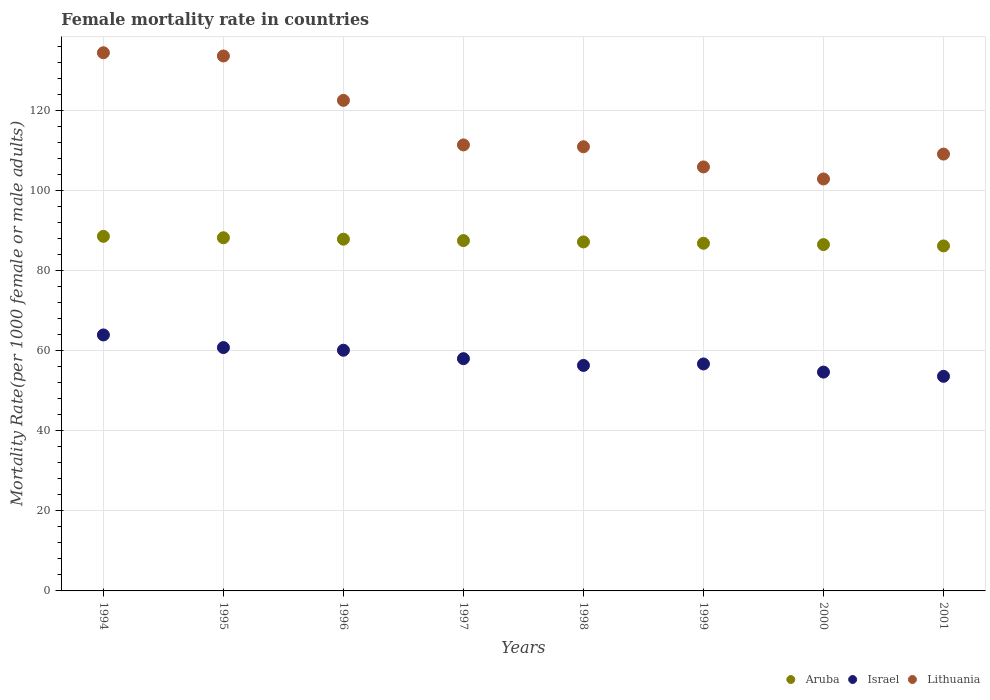Is the number of dotlines equal to the number of legend labels?
Make the answer very short. Yes. What is the female mortality rate in Lithuania in 1994?
Provide a succinct answer. 134.55. Across all years, what is the maximum female mortality rate in Lithuania?
Offer a terse response. 134.55. Across all years, what is the minimum female mortality rate in Israel?
Give a very brief answer. 53.65. In which year was the female mortality rate in Aruba minimum?
Your answer should be very brief. 2001. What is the total female mortality rate in Israel in the graph?
Offer a terse response. 464.58. What is the difference between the female mortality rate in Lithuania in 1998 and that in 2001?
Your response must be concise. 1.84. What is the difference between the female mortality rate in Lithuania in 1998 and the female mortality rate in Aruba in 1995?
Provide a succinct answer. 22.76. What is the average female mortality rate in Israel per year?
Offer a very short reply. 58.07. In the year 2000, what is the difference between the female mortality rate in Aruba and female mortality rate in Lithuania?
Offer a very short reply. -16.41. In how many years, is the female mortality rate in Israel greater than 4?
Offer a terse response. 8. What is the ratio of the female mortality rate in Israel in 1994 to that in 1999?
Your answer should be compact. 1.13. What is the difference between the highest and the second highest female mortality rate in Lithuania?
Your answer should be compact. 0.81. What is the difference between the highest and the lowest female mortality rate in Aruba?
Give a very brief answer. 2.4. Does the female mortality rate in Aruba monotonically increase over the years?
Provide a short and direct response. No. How many dotlines are there?
Your answer should be very brief. 3. Are the values on the major ticks of Y-axis written in scientific E-notation?
Provide a succinct answer. No. Does the graph contain any zero values?
Your answer should be very brief. No. Where does the legend appear in the graph?
Provide a short and direct response. Bottom right. How many legend labels are there?
Keep it short and to the point. 3. How are the legend labels stacked?
Give a very brief answer. Horizontal. What is the title of the graph?
Provide a short and direct response. Female mortality rate in countries. What is the label or title of the Y-axis?
Your answer should be very brief. Mortality Rate(per 1000 female or male adults). What is the Mortality Rate(per 1000 female or male adults) of Aruba in 1994?
Offer a terse response. 88.65. What is the Mortality Rate(per 1000 female or male adults) of Israel in 1994?
Provide a succinct answer. 64. What is the Mortality Rate(per 1000 female or male adults) of Lithuania in 1994?
Give a very brief answer. 134.55. What is the Mortality Rate(per 1000 female or male adults) of Aruba in 1995?
Keep it short and to the point. 88.3. What is the Mortality Rate(per 1000 female or male adults) in Israel in 1995?
Your answer should be very brief. 60.84. What is the Mortality Rate(per 1000 female or male adults) of Lithuania in 1995?
Keep it short and to the point. 133.74. What is the Mortality Rate(per 1000 female or male adults) of Aruba in 1996?
Your response must be concise. 87.94. What is the Mortality Rate(per 1000 female or male adults) in Israel in 1996?
Your answer should be very brief. 60.18. What is the Mortality Rate(per 1000 female or male adults) of Lithuania in 1996?
Make the answer very short. 122.65. What is the Mortality Rate(per 1000 female or male adults) in Aruba in 1997?
Give a very brief answer. 87.59. What is the Mortality Rate(per 1000 female or male adults) in Israel in 1997?
Offer a very short reply. 58.07. What is the Mortality Rate(per 1000 female or male adults) in Lithuania in 1997?
Offer a terse response. 111.5. What is the Mortality Rate(per 1000 female or male adults) in Aruba in 1998?
Your answer should be very brief. 87.25. What is the Mortality Rate(per 1000 female or male adults) in Israel in 1998?
Ensure brevity in your answer.  56.38. What is the Mortality Rate(per 1000 female or male adults) of Lithuania in 1998?
Provide a short and direct response. 111.05. What is the Mortality Rate(per 1000 female or male adults) of Aruba in 1999?
Your answer should be compact. 86.92. What is the Mortality Rate(per 1000 female or male adults) in Israel in 1999?
Keep it short and to the point. 56.74. What is the Mortality Rate(per 1000 female or male adults) in Lithuania in 1999?
Provide a short and direct response. 106. What is the Mortality Rate(per 1000 female or male adults) in Aruba in 2000?
Make the answer very short. 86.59. What is the Mortality Rate(per 1000 female or male adults) in Israel in 2000?
Your answer should be compact. 54.71. What is the Mortality Rate(per 1000 female or male adults) of Lithuania in 2000?
Give a very brief answer. 102.99. What is the Mortality Rate(per 1000 female or male adults) of Aruba in 2001?
Offer a very short reply. 86.25. What is the Mortality Rate(per 1000 female or male adults) in Israel in 2001?
Provide a succinct answer. 53.65. What is the Mortality Rate(per 1000 female or male adults) in Lithuania in 2001?
Make the answer very short. 109.22. Across all years, what is the maximum Mortality Rate(per 1000 female or male adults) of Aruba?
Provide a short and direct response. 88.65. Across all years, what is the maximum Mortality Rate(per 1000 female or male adults) in Israel?
Make the answer very short. 64. Across all years, what is the maximum Mortality Rate(per 1000 female or male adults) in Lithuania?
Offer a very short reply. 134.55. Across all years, what is the minimum Mortality Rate(per 1000 female or male adults) of Aruba?
Provide a succinct answer. 86.25. Across all years, what is the minimum Mortality Rate(per 1000 female or male adults) of Israel?
Your answer should be very brief. 53.65. Across all years, what is the minimum Mortality Rate(per 1000 female or male adults) of Lithuania?
Offer a terse response. 102.99. What is the total Mortality Rate(per 1000 female or male adults) in Aruba in the graph?
Your response must be concise. 699.5. What is the total Mortality Rate(per 1000 female or male adults) in Israel in the graph?
Your response must be concise. 464.58. What is the total Mortality Rate(per 1000 female or male adults) in Lithuania in the graph?
Keep it short and to the point. 931.71. What is the difference between the Mortality Rate(per 1000 female or male adults) in Aruba in 1994 and that in 1995?
Provide a succinct answer. 0.35. What is the difference between the Mortality Rate(per 1000 female or male adults) of Israel in 1994 and that in 1995?
Give a very brief answer. 3.16. What is the difference between the Mortality Rate(per 1000 female or male adults) of Lithuania in 1994 and that in 1995?
Make the answer very short. 0.81. What is the difference between the Mortality Rate(per 1000 female or male adults) in Aruba in 1994 and that in 1996?
Ensure brevity in your answer.  0.71. What is the difference between the Mortality Rate(per 1000 female or male adults) of Israel in 1994 and that in 1996?
Your response must be concise. 3.82. What is the difference between the Mortality Rate(per 1000 female or male adults) in Lithuania in 1994 and that in 1996?
Provide a succinct answer. 11.9. What is the difference between the Mortality Rate(per 1000 female or male adults) of Aruba in 1994 and that in 1997?
Give a very brief answer. 1.06. What is the difference between the Mortality Rate(per 1000 female or male adults) in Israel in 1994 and that in 1997?
Your response must be concise. 5.93. What is the difference between the Mortality Rate(per 1000 female or male adults) of Lithuania in 1994 and that in 1997?
Offer a very short reply. 23.05. What is the difference between the Mortality Rate(per 1000 female or male adults) in Aruba in 1994 and that in 1998?
Make the answer very short. 1.4. What is the difference between the Mortality Rate(per 1000 female or male adults) of Israel in 1994 and that in 1998?
Offer a very short reply. 7.62. What is the difference between the Mortality Rate(per 1000 female or male adults) in Lithuania in 1994 and that in 1998?
Offer a terse response. 23.5. What is the difference between the Mortality Rate(per 1000 female or male adults) in Aruba in 1994 and that in 1999?
Keep it short and to the point. 1.73. What is the difference between the Mortality Rate(per 1000 female or male adults) in Israel in 1994 and that in 1999?
Offer a very short reply. 7.25. What is the difference between the Mortality Rate(per 1000 female or male adults) of Lithuania in 1994 and that in 1999?
Your answer should be compact. 28.55. What is the difference between the Mortality Rate(per 1000 female or male adults) of Aruba in 1994 and that in 2000?
Offer a very short reply. 2.06. What is the difference between the Mortality Rate(per 1000 female or male adults) in Israel in 1994 and that in 2000?
Keep it short and to the point. 9.29. What is the difference between the Mortality Rate(per 1000 female or male adults) in Lithuania in 1994 and that in 2000?
Give a very brief answer. 31.56. What is the difference between the Mortality Rate(per 1000 female or male adults) in Aruba in 1994 and that in 2001?
Your answer should be compact. 2.4. What is the difference between the Mortality Rate(per 1000 female or male adults) in Israel in 1994 and that in 2001?
Provide a succinct answer. 10.35. What is the difference between the Mortality Rate(per 1000 female or male adults) of Lithuania in 1994 and that in 2001?
Provide a short and direct response. 25.34. What is the difference between the Mortality Rate(per 1000 female or male adults) in Aruba in 1995 and that in 1996?
Make the answer very short. 0.35. What is the difference between the Mortality Rate(per 1000 female or male adults) of Israel in 1995 and that in 1996?
Offer a terse response. 0.67. What is the difference between the Mortality Rate(per 1000 female or male adults) of Lithuania in 1995 and that in 1996?
Make the answer very short. 11.1. What is the difference between the Mortality Rate(per 1000 female or male adults) in Aruba in 1995 and that in 1997?
Your answer should be compact. 0.71. What is the difference between the Mortality Rate(per 1000 female or male adults) of Israel in 1995 and that in 1997?
Provide a short and direct response. 2.77. What is the difference between the Mortality Rate(per 1000 female or male adults) in Lithuania in 1995 and that in 1997?
Give a very brief answer. 22.24. What is the difference between the Mortality Rate(per 1000 female or male adults) of Aruba in 1995 and that in 1998?
Offer a very short reply. 1.04. What is the difference between the Mortality Rate(per 1000 female or male adults) of Israel in 1995 and that in 1998?
Ensure brevity in your answer.  4.46. What is the difference between the Mortality Rate(per 1000 female or male adults) of Lithuania in 1995 and that in 1998?
Keep it short and to the point. 22.69. What is the difference between the Mortality Rate(per 1000 female or male adults) in Aruba in 1995 and that in 1999?
Your answer should be very brief. 1.38. What is the difference between the Mortality Rate(per 1000 female or male adults) in Israel in 1995 and that in 1999?
Keep it short and to the point. 4.1. What is the difference between the Mortality Rate(per 1000 female or male adults) of Lithuania in 1995 and that in 1999?
Your answer should be compact. 27.74. What is the difference between the Mortality Rate(per 1000 female or male adults) of Aruba in 1995 and that in 2000?
Your answer should be very brief. 1.71. What is the difference between the Mortality Rate(per 1000 female or male adults) of Israel in 1995 and that in 2000?
Provide a succinct answer. 6.13. What is the difference between the Mortality Rate(per 1000 female or male adults) of Lithuania in 1995 and that in 2000?
Provide a short and direct response. 30.75. What is the difference between the Mortality Rate(per 1000 female or male adults) in Aruba in 1995 and that in 2001?
Your answer should be compact. 2.04. What is the difference between the Mortality Rate(per 1000 female or male adults) in Israel in 1995 and that in 2001?
Your answer should be very brief. 7.19. What is the difference between the Mortality Rate(per 1000 female or male adults) in Lithuania in 1995 and that in 2001?
Give a very brief answer. 24.53. What is the difference between the Mortality Rate(per 1000 female or male adults) of Aruba in 1996 and that in 1997?
Your answer should be very brief. 0.35. What is the difference between the Mortality Rate(per 1000 female or male adults) in Israel in 1996 and that in 1997?
Make the answer very short. 2.11. What is the difference between the Mortality Rate(per 1000 female or male adults) in Lithuania in 1996 and that in 1997?
Your answer should be compact. 11.14. What is the difference between the Mortality Rate(per 1000 female or male adults) of Aruba in 1996 and that in 1998?
Offer a terse response. 0.69. What is the difference between the Mortality Rate(per 1000 female or male adults) of Israel in 1996 and that in 1998?
Your answer should be compact. 3.8. What is the difference between the Mortality Rate(per 1000 female or male adults) in Lithuania in 1996 and that in 1998?
Give a very brief answer. 11.59. What is the difference between the Mortality Rate(per 1000 female or male adults) in Aruba in 1996 and that in 1999?
Ensure brevity in your answer.  1.02. What is the difference between the Mortality Rate(per 1000 female or male adults) of Israel in 1996 and that in 1999?
Give a very brief answer. 3.43. What is the difference between the Mortality Rate(per 1000 female or male adults) of Lithuania in 1996 and that in 1999?
Your answer should be compact. 16.64. What is the difference between the Mortality Rate(per 1000 female or male adults) of Aruba in 1996 and that in 2000?
Provide a short and direct response. 1.35. What is the difference between the Mortality Rate(per 1000 female or male adults) of Israel in 1996 and that in 2000?
Give a very brief answer. 5.47. What is the difference between the Mortality Rate(per 1000 female or male adults) of Lithuania in 1996 and that in 2000?
Your answer should be compact. 19.65. What is the difference between the Mortality Rate(per 1000 female or male adults) in Aruba in 1996 and that in 2001?
Provide a succinct answer. 1.69. What is the difference between the Mortality Rate(per 1000 female or male adults) in Israel in 1996 and that in 2001?
Your answer should be compact. 6.52. What is the difference between the Mortality Rate(per 1000 female or male adults) in Lithuania in 1996 and that in 2001?
Keep it short and to the point. 13.43. What is the difference between the Mortality Rate(per 1000 female or male adults) of Aruba in 1997 and that in 1998?
Give a very brief answer. 0.33. What is the difference between the Mortality Rate(per 1000 female or male adults) of Israel in 1997 and that in 1998?
Provide a succinct answer. 1.69. What is the difference between the Mortality Rate(per 1000 female or male adults) of Lithuania in 1997 and that in 1998?
Offer a terse response. 0.45. What is the difference between the Mortality Rate(per 1000 female or male adults) of Aruba in 1997 and that in 1999?
Your answer should be compact. 0.67. What is the difference between the Mortality Rate(per 1000 female or male adults) of Israel in 1997 and that in 1999?
Ensure brevity in your answer.  1.32. What is the difference between the Mortality Rate(per 1000 female or male adults) of Lithuania in 1997 and that in 1999?
Give a very brief answer. 5.5. What is the difference between the Mortality Rate(per 1000 female or male adults) in Israel in 1997 and that in 2000?
Give a very brief answer. 3.36. What is the difference between the Mortality Rate(per 1000 female or male adults) of Lithuania in 1997 and that in 2000?
Provide a short and direct response. 8.51. What is the difference between the Mortality Rate(per 1000 female or male adults) in Aruba in 1997 and that in 2001?
Ensure brevity in your answer.  1.33. What is the difference between the Mortality Rate(per 1000 female or male adults) of Israel in 1997 and that in 2001?
Offer a terse response. 4.42. What is the difference between the Mortality Rate(per 1000 female or male adults) in Lithuania in 1997 and that in 2001?
Provide a succinct answer. 2.29. What is the difference between the Mortality Rate(per 1000 female or male adults) in Aruba in 1998 and that in 1999?
Make the answer very short. 0.33. What is the difference between the Mortality Rate(per 1000 female or male adults) of Israel in 1998 and that in 1999?
Your answer should be compact. -0.37. What is the difference between the Mortality Rate(per 1000 female or male adults) in Lithuania in 1998 and that in 1999?
Keep it short and to the point. 5.05. What is the difference between the Mortality Rate(per 1000 female or male adults) in Aruba in 1998 and that in 2000?
Make the answer very short. 0.67. What is the difference between the Mortality Rate(per 1000 female or male adults) of Israel in 1998 and that in 2000?
Offer a terse response. 1.67. What is the difference between the Mortality Rate(per 1000 female or male adults) in Lithuania in 1998 and that in 2000?
Ensure brevity in your answer.  8.06. What is the difference between the Mortality Rate(per 1000 female or male adults) in Israel in 1998 and that in 2001?
Offer a very short reply. 2.73. What is the difference between the Mortality Rate(per 1000 female or male adults) of Lithuania in 1998 and that in 2001?
Your answer should be compact. 1.84. What is the difference between the Mortality Rate(per 1000 female or male adults) of Aruba in 1999 and that in 2000?
Your answer should be very brief. 0.33. What is the difference between the Mortality Rate(per 1000 female or male adults) in Israel in 1999 and that in 2000?
Offer a very short reply. 2.04. What is the difference between the Mortality Rate(per 1000 female or male adults) in Lithuania in 1999 and that in 2000?
Give a very brief answer. 3.01. What is the difference between the Mortality Rate(per 1000 female or male adults) in Aruba in 1999 and that in 2001?
Keep it short and to the point. 0.67. What is the difference between the Mortality Rate(per 1000 female or male adults) in Israel in 1999 and that in 2001?
Provide a succinct answer. 3.09. What is the difference between the Mortality Rate(per 1000 female or male adults) in Lithuania in 1999 and that in 2001?
Your response must be concise. -3.21. What is the difference between the Mortality Rate(per 1000 female or male adults) of Aruba in 2000 and that in 2001?
Provide a succinct answer. 0.33. What is the difference between the Mortality Rate(per 1000 female or male adults) of Israel in 2000 and that in 2001?
Keep it short and to the point. 1.06. What is the difference between the Mortality Rate(per 1000 female or male adults) in Lithuania in 2000 and that in 2001?
Keep it short and to the point. -6.22. What is the difference between the Mortality Rate(per 1000 female or male adults) of Aruba in 1994 and the Mortality Rate(per 1000 female or male adults) of Israel in 1995?
Provide a short and direct response. 27.81. What is the difference between the Mortality Rate(per 1000 female or male adults) in Aruba in 1994 and the Mortality Rate(per 1000 female or male adults) in Lithuania in 1995?
Provide a succinct answer. -45.09. What is the difference between the Mortality Rate(per 1000 female or male adults) of Israel in 1994 and the Mortality Rate(per 1000 female or male adults) of Lithuania in 1995?
Ensure brevity in your answer.  -69.74. What is the difference between the Mortality Rate(per 1000 female or male adults) of Aruba in 1994 and the Mortality Rate(per 1000 female or male adults) of Israel in 1996?
Give a very brief answer. 28.48. What is the difference between the Mortality Rate(per 1000 female or male adults) in Aruba in 1994 and the Mortality Rate(per 1000 female or male adults) in Lithuania in 1996?
Your answer should be very brief. -33.99. What is the difference between the Mortality Rate(per 1000 female or male adults) of Israel in 1994 and the Mortality Rate(per 1000 female or male adults) of Lithuania in 1996?
Offer a very short reply. -58.65. What is the difference between the Mortality Rate(per 1000 female or male adults) of Aruba in 1994 and the Mortality Rate(per 1000 female or male adults) of Israel in 1997?
Ensure brevity in your answer.  30.58. What is the difference between the Mortality Rate(per 1000 female or male adults) in Aruba in 1994 and the Mortality Rate(per 1000 female or male adults) in Lithuania in 1997?
Give a very brief answer. -22.85. What is the difference between the Mortality Rate(per 1000 female or male adults) of Israel in 1994 and the Mortality Rate(per 1000 female or male adults) of Lithuania in 1997?
Keep it short and to the point. -47.51. What is the difference between the Mortality Rate(per 1000 female or male adults) of Aruba in 1994 and the Mortality Rate(per 1000 female or male adults) of Israel in 1998?
Make the answer very short. 32.27. What is the difference between the Mortality Rate(per 1000 female or male adults) of Aruba in 1994 and the Mortality Rate(per 1000 female or male adults) of Lithuania in 1998?
Your answer should be very brief. -22.4. What is the difference between the Mortality Rate(per 1000 female or male adults) in Israel in 1994 and the Mortality Rate(per 1000 female or male adults) in Lithuania in 1998?
Provide a short and direct response. -47.05. What is the difference between the Mortality Rate(per 1000 female or male adults) of Aruba in 1994 and the Mortality Rate(per 1000 female or male adults) of Israel in 1999?
Your response must be concise. 31.91. What is the difference between the Mortality Rate(per 1000 female or male adults) of Aruba in 1994 and the Mortality Rate(per 1000 female or male adults) of Lithuania in 1999?
Ensure brevity in your answer.  -17.35. What is the difference between the Mortality Rate(per 1000 female or male adults) of Israel in 1994 and the Mortality Rate(per 1000 female or male adults) of Lithuania in 1999?
Give a very brief answer. -42.01. What is the difference between the Mortality Rate(per 1000 female or male adults) in Aruba in 1994 and the Mortality Rate(per 1000 female or male adults) in Israel in 2000?
Provide a succinct answer. 33.94. What is the difference between the Mortality Rate(per 1000 female or male adults) of Aruba in 1994 and the Mortality Rate(per 1000 female or male adults) of Lithuania in 2000?
Your answer should be compact. -14.34. What is the difference between the Mortality Rate(per 1000 female or male adults) of Israel in 1994 and the Mortality Rate(per 1000 female or male adults) of Lithuania in 2000?
Your answer should be very brief. -38.99. What is the difference between the Mortality Rate(per 1000 female or male adults) of Aruba in 1994 and the Mortality Rate(per 1000 female or male adults) of Israel in 2001?
Provide a short and direct response. 35. What is the difference between the Mortality Rate(per 1000 female or male adults) of Aruba in 1994 and the Mortality Rate(per 1000 female or male adults) of Lithuania in 2001?
Keep it short and to the point. -20.56. What is the difference between the Mortality Rate(per 1000 female or male adults) in Israel in 1994 and the Mortality Rate(per 1000 female or male adults) in Lithuania in 2001?
Give a very brief answer. -45.22. What is the difference between the Mortality Rate(per 1000 female or male adults) in Aruba in 1995 and the Mortality Rate(per 1000 female or male adults) in Israel in 1996?
Offer a very short reply. 28.12. What is the difference between the Mortality Rate(per 1000 female or male adults) of Aruba in 1995 and the Mortality Rate(per 1000 female or male adults) of Lithuania in 1996?
Give a very brief answer. -34.35. What is the difference between the Mortality Rate(per 1000 female or male adults) in Israel in 1995 and the Mortality Rate(per 1000 female or male adults) in Lithuania in 1996?
Make the answer very short. -61.8. What is the difference between the Mortality Rate(per 1000 female or male adults) in Aruba in 1995 and the Mortality Rate(per 1000 female or male adults) in Israel in 1997?
Offer a terse response. 30.23. What is the difference between the Mortality Rate(per 1000 female or male adults) of Aruba in 1995 and the Mortality Rate(per 1000 female or male adults) of Lithuania in 1997?
Provide a succinct answer. -23.21. What is the difference between the Mortality Rate(per 1000 female or male adults) in Israel in 1995 and the Mortality Rate(per 1000 female or male adults) in Lithuania in 1997?
Provide a succinct answer. -50.66. What is the difference between the Mortality Rate(per 1000 female or male adults) in Aruba in 1995 and the Mortality Rate(per 1000 female or male adults) in Israel in 1998?
Keep it short and to the point. 31.92. What is the difference between the Mortality Rate(per 1000 female or male adults) of Aruba in 1995 and the Mortality Rate(per 1000 female or male adults) of Lithuania in 1998?
Make the answer very short. -22.75. What is the difference between the Mortality Rate(per 1000 female or male adults) of Israel in 1995 and the Mortality Rate(per 1000 female or male adults) of Lithuania in 1998?
Your response must be concise. -50.21. What is the difference between the Mortality Rate(per 1000 female or male adults) in Aruba in 1995 and the Mortality Rate(per 1000 female or male adults) in Israel in 1999?
Give a very brief answer. 31.55. What is the difference between the Mortality Rate(per 1000 female or male adults) in Aruba in 1995 and the Mortality Rate(per 1000 female or male adults) in Lithuania in 1999?
Provide a short and direct response. -17.71. What is the difference between the Mortality Rate(per 1000 female or male adults) of Israel in 1995 and the Mortality Rate(per 1000 female or male adults) of Lithuania in 1999?
Provide a succinct answer. -45.16. What is the difference between the Mortality Rate(per 1000 female or male adults) in Aruba in 1995 and the Mortality Rate(per 1000 female or male adults) in Israel in 2000?
Give a very brief answer. 33.59. What is the difference between the Mortality Rate(per 1000 female or male adults) in Aruba in 1995 and the Mortality Rate(per 1000 female or male adults) in Lithuania in 2000?
Keep it short and to the point. -14.7. What is the difference between the Mortality Rate(per 1000 female or male adults) in Israel in 1995 and the Mortality Rate(per 1000 female or male adults) in Lithuania in 2000?
Your answer should be compact. -42.15. What is the difference between the Mortality Rate(per 1000 female or male adults) in Aruba in 1995 and the Mortality Rate(per 1000 female or male adults) in Israel in 2001?
Keep it short and to the point. 34.64. What is the difference between the Mortality Rate(per 1000 female or male adults) of Aruba in 1995 and the Mortality Rate(per 1000 female or male adults) of Lithuania in 2001?
Make the answer very short. -20.92. What is the difference between the Mortality Rate(per 1000 female or male adults) of Israel in 1995 and the Mortality Rate(per 1000 female or male adults) of Lithuania in 2001?
Ensure brevity in your answer.  -48.37. What is the difference between the Mortality Rate(per 1000 female or male adults) in Aruba in 1996 and the Mortality Rate(per 1000 female or male adults) in Israel in 1997?
Keep it short and to the point. 29.87. What is the difference between the Mortality Rate(per 1000 female or male adults) of Aruba in 1996 and the Mortality Rate(per 1000 female or male adults) of Lithuania in 1997?
Provide a succinct answer. -23.56. What is the difference between the Mortality Rate(per 1000 female or male adults) of Israel in 1996 and the Mortality Rate(per 1000 female or male adults) of Lithuania in 1997?
Offer a terse response. -51.33. What is the difference between the Mortality Rate(per 1000 female or male adults) in Aruba in 1996 and the Mortality Rate(per 1000 female or male adults) in Israel in 1998?
Offer a very short reply. 31.56. What is the difference between the Mortality Rate(per 1000 female or male adults) in Aruba in 1996 and the Mortality Rate(per 1000 female or male adults) in Lithuania in 1998?
Provide a short and direct response. -23.11. What is the difference between the Mortality Rate(per 1000 female or male adults) in Israel in 1996 and the Mortality Rate(per 1000 female or male adults) in Lithuania in 1998?
Provide a short and direct response. -50.88. What is the difference between the Mortality Rate(per 1000 female or male adults) in Aruba in 1996 and the Mortality Rate(per 1000 female or male adults) in Israel in 1999?
Your response must be concise. 31.2. What is the difference between the Mortality Rate(per 1000 female or male adults) in Aruba in 1996 and the Mortality Rate(per 1000 female or male adults) in Lithuania in 1999?
Your answer should be very brief. -18.06. What is the difference between the Mortality Rate(per 1000 female or male adults) of Israel in 1996 and the Mortality Rate(per 1000 female or male adults) of Lithuania in 1999?
Give a very brief answer. -45.83. What is the difference between the Mortality Rate(per 1000 female or male adults) in Aruba in 1996 and the Mortality Rate(per 1000 female or male adults) in Israel in 2000?
Keep it short and to the point. 33.23. What is the difference between the Mortality Rate(per 1000 female or male adults) of Aruba in 1996 and the Mortality Rate(per 1000 female or male adults) of Lithuania in 2000?
Offer a very short reply. -15.05. What is the difference between the Mortality Rate(per 1000 female or male adults) in Israel in 1996 and the Mortality Rate(per 1000 female or male adults) in Lithuania in 2000?
Make the answer very short. -42.82. What is the difference between the Mortality Rate(per 1000 female or male adults) in Aruba in 1996 and the Mortality Rate(per 1000 female or male adults) in Israel in 2001?
Keep it short and to the point. 34.29. What is the difference between the Mortality Rate(per 1000 female or male adults) in Aruba in 1996 and the Mortality Rate(per 1000 female or male adults) in Lithuania in 2001?
Offer a very short reply. -21.27. What is the difference between the Mortality Rate(per 1000 female or male adults) in Israel in 1996 and the Mortality Rate(per 1000 female or male adults) in Lithuania in 2001?
Offer a very short reply. -49.04. What is the difference between the Mortality Rate(per 1000 female or male adults) of Aruba in 1997 and the Mortality Rate(per 1000 female or male adults) of Israel in 1998?
Offer a very short reply. 31.21. What is the difference between the Mortality Rate(per 1000 female or male adults) of Aruba in 1997 and the Mortality Rate(per 1000 female or male adults) of Lithuania in 1998?
Your answer should be compact. -23.46. What is the difference between the Mortality Rate(per 1000 female or male adults) in Israel in 1997 and the Mortality Rate(per 1000 female or male adults) in Lithuania in 1998?
Keep it short and to the point. -52.98. What is the difference between the Mortality Rate(per 1000 female or male adults) in Aruba in 1997 and the Mortality Rate(per 1000 female or male adults) in Israel in 1999?
Your answer should be very brief. 30.84. What is the difference between the Mortality Rate(per 1000 female or male adults) in Aruba in 1997 and the Mortality Rate(per 1000 female or male adults) in Lithuania in 1999?
Provide a succinct answer. -18.42. What is the difference between the Mortality Rate(per 1000 female or male adults) in Israel in 1997 and the Mortality Rate(per 1000 female or male adults) in Lithuania in 1999?
Provide a succinct answer. -47.94. What is the difference between the Mortality Rate(per 1000 female or male adults) of Aruba in 1997 and the Mortality Rate(per 1000 female or male adults) of Israel in 2000?
Your answer should be very brief. 32.88. What is the difference between the Mortality Rate(per 1000 female or male adults) of Aruba in 1997 and the Mortality Rate(per 1000 female or male adults) of Lithuania in 2000?
Your answer should be compact. -15.4. What is the difference between the Mortality Rate(per 1000 female or male adults) of Israel in 1997 and the Mortality Rate(per 1000 female or male adults) of Lithuania in 2000?
Ensure brevity in your answer.  -44.92. What is the difference between the Mortality Rate(per 1000 female or male adults) in Aruba in 1997 and the Mortality Rate(per 1000 female or male adults) in Israel in 2001?
Your answer should be very brief. 33.94. What is the difference between the Mortality Rate(per 1000 female or male adults) in Aruba in 1997 and the Mortality Rate(per 1000 female or male adults) in Lithuania in 2001?
Provide a succinct answer. -21.63. What is the difference between the Mortality Rate(per 1000 female or male adults) in Israel in 1997 and the Mortality Rate(per 1000 female or male adults) in Lithuania in 2001?
Provide a short and direct response. -51.15. What is the difference between the Mortality Rate(per 1000 female or male adults) of Aruba in 1998 and the Mortality Rate(per 1000 female or male adults) of Israel in 1999?
Give a very brief answer. 30.51. What is the difference between the Mortality Rate(per 1000 female or male adults) in Aruba in 1998 and the Mortality Rate(per 1000 female or male adults) in Lithuania in 1999?
Keep it short and to the point. -18.75. What is the difference between the Mortality Rate(per 1000 female or male adults) in Israel in 1998 and the Mortality Rate(per 1000 female or male adults) in Lithuania in 1999?
Your answer should be very brief. -49.63. What is the difference between the Mortality Rate(per 1000 female or male adults) in Aruba in 1998 and the Mortality Rate(per 1000 female or male adults) in Israel in 2000?
Your answer should be very brief. 32.55. What is the difference between the Mortality Rate(per 1000 female or male adults) of Aruba in 1998 and the Mortality Rate(per 1000 female or male adults) of Lithuania in 2000?
Offer a very short reply. -15.74. What is the difference between the Mortality Rate(per 1000 female or male adults) of Israel in 1998 and the Mortality Rate(per 1000 female or male adults) of Lithuania in 2000?
Make the answer very short. -46.62. What is the difference between the Mortality Rate(per 1000 female or male adults) of Aruba in 1998 and the Mortality Rate(per 1000 female or male adults) of Israel in 2001?
Provide a short and direct response. 33.6. What is the difference between the Mortality Rate(per 1000 female or male adults) of Aruba in 1998 and the Mortality Rate(per 1000 female or male adults) of Lithuania in 2001?
Offer a terse response. -21.96. What is the difference between the Mortality Rate(per 1000 female or male adults) of Israel in 1998 and the Mortality Rate(per 1000 female or male adults) of Lithuania in 2001?
Keep it short and to the point. -52.84. What is the difference between the Mortality Rate(per 1000 female or male adults) of Aruba in 1999 and the Mortality Rate(per 1000 female or male adults) of Israel in 2000?
Make the answer very short. 32.21. What is the difference between the Mortality Rate(per 1000 female or male adults) in Aruba in 1999 and the Mortality Rate(per 1000 female or male adults) in Lithuania in 2000?
Make the answer very short. -16.07. What is the difference between the Mortality Rate(per 1000 female or male adults) of Israel in 1999 and the Mortality Rate(per 1000 female or male adults) of Lithuania in 2000?
Your answer should be very brief. -46.25. What is the difference between the Mortality Rate(per 1000 female or male adults) of Aruba in 1999 and the Mortality Rate(per 1000 female or male adults) of Israel in 2001?
Keep it short and to the point. 33.27. What is the difference between the Mortality Rate(per 1000 female or male adults) of Aruba in 1999 and the Mortality Rate(per 1000 female or male adults) of Lithuania in 2001?
Offer a terse response. -22.29. What is the difference between the Mortality Rate(per 1000 female or male adults) in Israel in 1999 and the Mortality Rate(per 1000 female or male adults) in Lithuania in 2001?
Your answer should be very brief. -52.47. What is the difference between the Mortality Rate(per 1000 female or male adults) in Aruba in 2000 and the Mortality Rate(per 1000 female or male adults) in Israel in 2001?
Provide a short and direct response. 32.93. What is the difference between the Mortality Rate(per 1000 female or male adults) of Aruba in 2000 and the Mortality Rate(per 1000 female or male adults) of Lithuania in 2001?
Provide a succinct answer. -22.63. What is the difference between the Mortality Rate(per 1000 female or male adults) in Israel in 2000 and the Mortality Rate(per 1000 female or male adults) in Lithuania in 2001?
Offer a terse response. -54.51. What is the average Mortality Rate(per 1000 female or male adults) of Aruba per year?
Offer a terse response. 87.44. What is the average Mortality Rate(per 1000 female or male adults) of Israel per year?
Offer a terse response. 58.07. What is the average Mortality Rate(per 1000 female or male adults) of Lithuania per year?
Offer a terse response. 116.46. In the year 1994, what is the difference between the Mortality Rate(per 1000 female or male adults) in Aruba and Mortality Rate(per 1000 female or male adults) in Israel?
Provide a short and direct response. 24.65. In the year 1994, what is the difference between the Mortality Rate(per 1000 female or male adults) in Aruba and Mortality Rate(per 1000 female or male adults) in Lithuania?
Give a very brief answer. -45.9. In the year 1994, what is the difference between the Mortality Rate(per 1000 female or male adults) in Israel and Mortality Rate(per 1000 female or male adults) in Lithuania?
Provide a short and direct response. -70.55. In the year 1995, what is the difference between the Mortality Rate(per 1000 female or male adults) in Aruba and Mortality Rate(per 1000 female or male adults) in Israel?
Offer a very short reply. 27.45. In the year 1995, what is the difference between the Mortality Rate(per 1000 female or male adults) in Aruba and Mortality Rate(per 1000 female or male adults) in Lithuania?
Your response must be concise. -45.44. In the year 1995, what is the difference between the Mortality Rate(per 1000 female or male adults) in Israel and Mortality Rate(per 1000 female or male adults) in Lithuania?
Keep it short and to the point. -72.9. In the year 1996, what is the difference between the Mortality Rate(per 1000 female or male adults) in Aruba and Mortality Rate(per 1000 female or male adults) in Israel?
Give a very brief answer. 27.77. In the year 1996, what is the difference between the Mortality Rate(per 1000 female or male adults) of Aruba and Mortality Rate(per 1000 female or male adults) of Lithuania?
Provide a short and direct response. -34.7. In the year 1996, what is the difference between the Mortality Rate(per 1000 female or male adults) of Israel and Mortality Rate(per 1000 female or male adults) of Lithuania?
Offer a terse response. -62.47. In the year 1997, what is the difference between the Mortality Rate(per 1000 female or male adults) of Aruba and Mortality Rate(per 1000 female or male adults) of Israel?
Your response must be concise. 29.52. In the year 1997, what is the difference between the Mortality Rate(per 1000 female or male adults) of Aruba and Mortality Rate(per 1000 female or male adults) of Lithuania?
Offer a very short reply. -23.91. In the year 1997, what is the difference between the Mortality Rate(per 1000 female or male adults) of Israel and Mortality Rate(per 1000 female or male adults) of Lithuania?
Provide a short and direct response. -53.43. In the year 1998, what is the difference between the Mortality Rate(per 1000 female or male adults) of Aruba and Mortality Rate(per 1000 female or male adults) of Israel?
Keep it short and to the point. 30.88. In the year 1998, what is the difference between the Mortality Rate(per 1000 female or male adults) in Aruba and Mortality Rate(per 1000 female or male adults) in Lithuania?
Give a very brief answer. -23.8. In the year 1998, what is the difference between the Mortality Rate(per 1000 female or male adults) of Israel and Mortality Rate(per 1000 female or male adults) of Lithuania?
Provide a succinct answer. -54.67. In the year 1999, what is the difference between the Mortality Rate(per 1000 female or male adults) of Aruba and Mortality Rate(per 1000 female or male adults) of Israel?
Provide a succinct answer. 30.18. In the year 1999, what is the difference between the Mortality Rate(per 1000 female or male adults) of Aruba and Mortality Rate(per 1000 female or male adults) of Lithuania?
Provide a short and direct response. -19.08. In the year 1999, what is the difference between the Mortality Rate(per 1000 female or male adults) in Israel and Mortality Rate(per 1000 female or male adults) in Lithuania?
Your answer should be compact. -49.26. In the year 2000, what is the difference between the Mortality Rate(per 1000 female or male adults) of Aruba and Mortality Rate(per 1000 female or male adults) of Israel?
Provide a succinct answer. 31.88. In the year 2000, what is the difference between the Mortality Rate(per 1000 female or male adults) of Aruba and Mortality Rate(per 1000 female or male adults) of Lithuania?
Make the answer very short. -16.41. In the year 2000, what is the difference between the Mortality Rate(per 1000 female or male adults) of Israel and Mortality Rate(per 1000 female or male adults) of Lithuania?
Your answer should be compact. -48.28. In the year 2001, what is the difference between the Mortality Rate(per 1000 female or male adults) in Aruba and Mortality Rate(per 1000 female or male adults) in Israel?
Your response must be concise. 32.6. In the year 2001, what is the difference between the Mortality Rate(per 1000 female or male adults) of Aruba and Mortality Rate(per 1000 female or male adults) of Lithuania?
Give a very brief answer. -22.96. In the year 2001, what is the difference between the Mortality Rate(per 1000 female or male adults) of Israel and Mortality Rate(per 1000 female or male adults) of Lithuania?
Your answer should be compact. -55.56. What is the ratio of the Mortality Rate(per 1000 female or male adults) of Israel in 1994 to that in 1995?
Your answer should be compact. 1.05. What is the ratio of the Mortality Rate(per 1000 female or male adults) in Israel in 1994 to that in 1996?
Provide a short and direct response. 1.06. What is the ratio of the Mortality Rate(per 1000 female or male adults) in Lithuania in 1994 to that in 1996?
Offer a very short reply. 1.1. What is the ratio of the Mortality Rate(per 1000 female or male adults) of Aruba in 1994 to that in 1997?
Provide a short and direct response. 1.01. What is the ratio of the Mortality Rate(per 1000 female or male adults) of Israel in 1994 to that in 1997?
Provide a succinct answer. 1.1. What is the ratio of the Mortality Rate(per 1000 female or male adults) of Lithuania in 1994 to that in 1997?
Provide a short and direct response. 1.21. What is the ratio of the Mortality Rate(per 1000 female or male adults) of Israel in 1994 to that in 1998?
Make the answer very short. 1.14. What is the ratio of the Mortality Rate(per 1000 female or male adults) of Lithuania in 1994 to that in 1998?
Give a very brief answer. 1.21. What is the ratio of the Mortality Rate(per 1000 female or male adults) of Aruba in 1994 to that in 1999?
Your response must be concise. 1.02. What is the ratio of the Mortality Rate(per 1000 female or male adults) in Israel in 1994 to that in 1999?
Your response must be concise. 1.13. What is the ratio of the Mortality Rate(per 1000 female or male adults) in Lithuania in 1994 to that in 1999?
Give a very brief answer. 1.27. What is the ratio of the Mortality Rate(per 1000 female or male adults) of Aruba in 1994 to that in 2000?
Offer a terse response. 1.02. What is the ratio of the Mortality Rate(per 1000 female or male adults) of Israel in 1994 to that in 2000?
Keep it short and to the point. 1.17. What is the ratio of the Mortality Rate(per 1000 female or male adults) in Lithuania in 1994 to that in 2000?
Your response must be concise. 1.31. What is the ratio of the Mortality Rate(per 1000 female or male adults) in Aruba in 1994 to that in 2001?
Provide a short and direct response. 1.03. What is the ratio of the Mortality Rate(per 1000 female or male adults) in Israel in 1994 to that in 2001?
Give a very brief answer. 1.19. What is the ratio of the Mortality Rate(per 1000 female or male adults) of Lithuania in 1994 to that in 2001?
Your answer should be compact. 1.23. What is the ratio of the Mortality Rate(per 1000 female or male adults) of Israel in 1995 to that in 1996?
Ensure brevity in your answer.  1.01. What is the ratio of the Mortality Rate(per 1000 female or male adults) of Lithuania in 1995 to that in 1996?
Provide a short and direct response. 1.09. What is the ratio of the Mortality Rate(per 1000 female or male adults) of Israel in 1995 to that in 1997?
Make the answer very short. 1.05. What is the ratio of the Mortality Rate(per 1000 female or male adults) of Lithuania in 1995 to that in 1997?
Offer a terse response. 1.2. What is the ratio of the Mortality Rate(per 1000 female or male adults) in Israel in 1995 to that in 1998?
Your answer should be very brief. 1.08. What is the ratio of the Mortality Rate(per 1000 female or male adults) in Lithuania in 1995 to that in 1998?
Provide a short and direct response. 1.2. What is the ratio of the Mortality Rate(per 1000 female or male adults) in Aruba in 1995 to that in 1999?
Your answer should be compact. 1.02. What is the ratio of the Mortality Rate(per 1000 female or male adults) in Israel in 1995 to that in 1999?
Your answer should be very brief. 1.07. What is the ratio of the Mortality Rate(per 1000 female or male adults) in Lithuania in 1995 to that in 1999?
Your answer should be very brief. 1.26. What is the ratio of the Mortality Rate(per 1000 female or male adults) in Aruba in 1995 to that in 2000?
Provide a succinct answer. 1.02. What is the ratio of the Mortality Rate(per 1000 female or male adults) in Israel in 1995 to that in 2000?
Offer a very short reply. 1.11. What is the ratio of the Mortality Rate(per 1000 female or male adults) in Lithuania in 1995 to that in 2000?
Keep it short and to the point. 1.3. What is the ratio of the Mortality Rate(per 1000 female or male adults) of Aruba in 1995 to that in 2001?
Your response must be concise. 1.02. What is the ratio of the Mortality Rate(per 1000 female or male adults) in Israel in 1995 to that in 2001?
Make the answer very short. 1.13. What is the ratio of the Mortality Rate(per 1000 female or male adults) in Lithuania in 1995 to that in 2001?
Ensure brevity in your answer.  1.22. What is the ratio of the Mortality Rate(per 1000 female or male adults) in Israel in 1996 to that in 1997?
Your response must be concise. 1.04. What is the ratio of the Mortality Rate(per 1000 female or male adults) of Lithuania in 1996 to that in 1997?
Provide a short and direct response. 1.1. What is the ratio of the Mortality Rate(per 1000 female or male adults) of Aruba in 1996 to that in 1998?
Your answer should be compact. 1.01. What is the ratio of the Mortality Rate(per 1000 female or male adults) in Israel in 1996 to that in 1998?
Provide a succinct answer. 1.07. What is the ratio of the Mortality Rate(per 1000 female or male adults) of Lithuania in 1996 to that in 1998?
Your answer should be compact. 1.1. What is the ratio of the Mortality Rate(per 1000 female or male adults) in Aruba in 1996 to that in 1999?
Your answer should be compact. 1.01. What is the ratio of the Mortality Rate(per 1000 female or male adults) in Israel in 1996 to that in 1999?
Ensure brevity in your answer.  1.06. What is the ratio of the Mortality Rate(per 1000 female or male adults) of Lithuania in 1996 to that in 1999?
Keep it short and to the point. 1.16. What is the ratio of the Mortality Rate(per 1000 female or male adults) of Aruba in 1996 to that in 2000?
Your answer should be very brief. 1.02. What is the ratio of the Mortality Rate(per 1000 female or male adults) in Israel in 1996 to that in 2000?
Your answer should be very brief. 1.1. What is the ratio of the Mortality Rate(per 1000 female or male adults) in Lithuania in 1996 to that in 2000?
Make the answer very short. 1.19. What is the ratio of the Mortality Rate(per 1000 female or male adults) in Aruba in 1996 to that in 2001?
Make the answer very short. 1.02. What is the ratio of the Mortality Rate(per 1000 female or male adults) of Israel in 1996 to that in 2001?
Keep it short and to the point. 1.12. What is the ratio of the Mortality Rate(per 1000 female or male adults) in Lithuania in 1996 to that in 2001?
Ensure brevity in your answer.  1.12. What is the ratio of the Mortality Rate(per 1000 female or male adults) in Aruba in 1997 to that in 1998?
Provide a short and direct response. 1. What is the ratio of the Mortality Rate(per 1000 female or male adults) of Aruba in 1997 to that in 1999?
Offer a very short reply. 1.01. What is the ratio of the Mortality Rate(per 1000 female or male adults) of Israel in 1997 to that in 1999?
Keep it short and to the point. 1.02. What is the ratio of the Mortality Rate(per 1000 female or male adults) of Lithuania in 1997 to that in 1999?
Make the answer very short. 1.05. What is the ratio of the Mortality Rate(per 1000 female or male adults) in Aruba in 1997 to that in 2000?
Offer a terse response. 1.01. What is the ratio of the Mortality Rate(per 1000 female or male adults) of Israel in 1997 to that in 2000?
Give a very brief answer. 1.06. What is the ratio of the Mortality Rate(per 1000 female or male adults) of Lithuania in 1997 to that in 2000?
Give a very brief answer. 1.08. What is the ratio of the Mortality Rate(per 1000 female or male adults) in Aruba in 1997 to that in 2001?
Ensure brevity in your answer.  1.02. What is the ratio of the Mortality Rate(per 1000 female or male adults) of Israel in 1997 to that in 2001?
Keep it short and to the point. 1.08. What is the ratio of the Mortality Rate(per 1000 female or male adults) in Lithuania in 1997 to that in 2001?
Ensure brevity in your answer.  1.02. What is the ratio of the Mortality Rate(per 1000 female or male adults) of Lithuania in 1998 to that in 1999?
Give a very brief answer. 1.05. What is the ratio of the Mortality Rate(per 1000 female or male adults) of Aruba in 1998 to that in 2000?
Your answer should be very brief. 1.01. What is the ratio of the Mortality Rate(per 1000 female or male adults) in Israel in 1998 to that in 2000?
Give a very brief answer. 1.03. What is the ratio of the Mortality Rate(per 1000 female or male adults) of Lithuania in 1998 to that in 2000?
Ensure brevity in your answer.  1.08. What is the ratio of the Mortality Rate(per 1000 female or male adults) of Aruba in 1998 to that in 2001?
Give a very brief answer. 1.01. What is the ratio of the Mortality Rate(per 1000 female or male adults) in Israel in 1998 to that in 2001?
Keep it short and to the point. 1.05. What is the ratio of the Mortality Rate(per 1000 female or male adults) in Lithuania in 1998 to that in 2001?
Offer a very short reply. 1.02. What is the ratio of the Mortality Rate(per 1000 female or male adults) in Israel in 1999 to that in 2000?
Keep it short and to the point. 1.04. What is the ratio of the Mortality Rate(per 1000 female or male adults) in Lithuania in 1999 to that in 2000?
Your answer should be compact. 1.03. What is the ratio of the Mortality Rate(per 1000 female or male adults) in Aruba in 1999 to that in 2001?
Keep it short and to the point. 1.01. What is the ratio of the Mortality Rate(per 1000 female or male adults) in Israel in 1999 to that in 2001?
Keep it short and to the point. 1.06. What is the ratio of the Mortality Rate(per 1000 female or male adults) of Lithuania in 1999 to that in 2001?
Provide a succinct answer. 0.97. What is the ratio of the Mortality Rate(per 1000 female or male adults) in Aruba in 2000 to that in 2001?
Provide a succinct answer. 1. What is the ratio of the Mortality Rate(per 1000 female or male adults) in Israel in 2000 to that in 2001?
Your answer should be very brief. 1.02. What is the ratio of the Mortality Rate(per 1000 female or male adults) in Lithuania in 2000 to that in 2001?
Provide a short and direct response. 0.94. What is the difference between the highest and the second highest Mortality Rate(per 1000 female or male adults) of Aruba?
Your answer should be very brief. 0.35. What is the difference between the highest and the second highest Mortality Rate(per 1000 female or male adults) in Israel?
Provide a succinct answer. 3.16. What is the difference between the highest and the second highest Mortality Rate(per 1000 female or male adults) of Lithuania?
Provide a short and direct response. 0.81. What is the difference between the highest and the lowest Mortality Rate(per 1000 female or male adults) of Aruba?
Provide a succinct answer. 2.4. What is the difference between the highest and the lowest Mortality Rate(per 1000 female or male adults) of Israel?
Keep it short and to the point. 10.35. What is the difference between the highest and the lowest Mortality Rate(per 1000 female or male adults) of Lithuania?
Give a very brief answer. 31.56. 